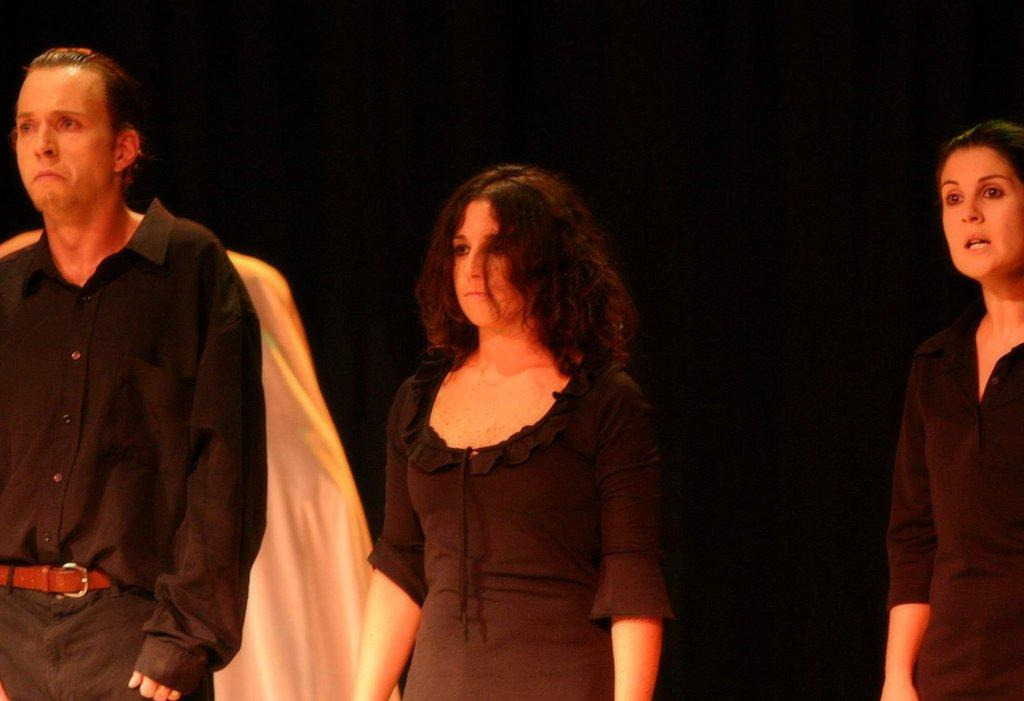What is happening in the image? There are people standing in the image. What are the people wearing? The people are wearing black dresses. What can be seen in the background of the image? There is a white cloth in the background of the image. What type of juice is being served in the image? There is no juice present in the image; it features people standing in black dresses with a white cloth in the background. What is the iron used for in the image? There is no iron present in the image. 